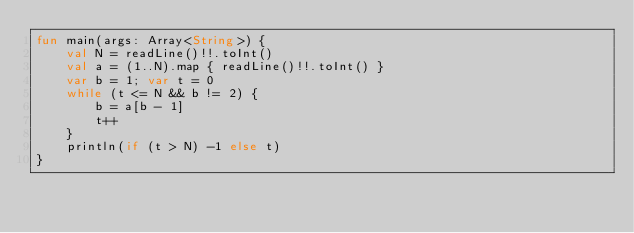Convert code to text. <code><loc_0><loc_0><loc_500><loc_500><_Kotlin_>fun main(args: Array<String>) {
    val N = readLine()!!.toInt()
    val a = (1..N).map { readLine()!!.toInt() }
    var b = 1; var t = 0
    while (t <= N && b != 2) {
        b = a[b - 1]
        t++
    }
    println(if (t > N) -1 else t)
}</code> 